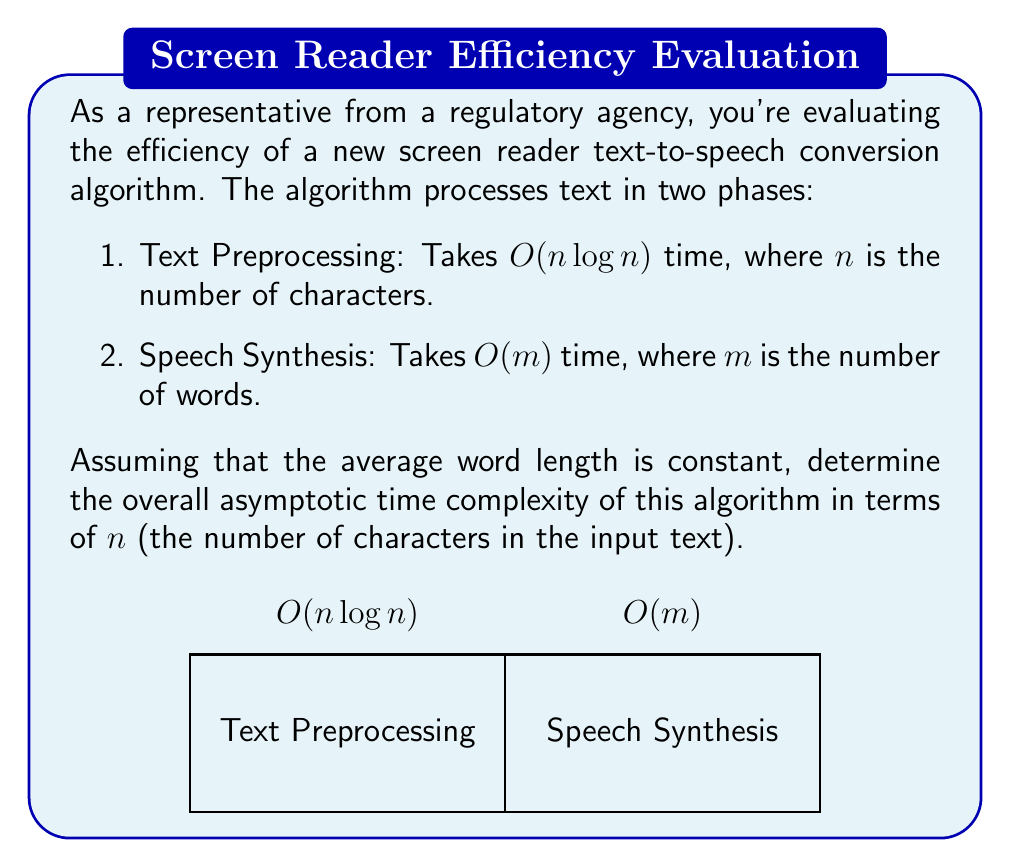Can you solve this math problem? To determine the overall asymptotic time complexity, we need to analyze both phases of the algorithm:

1. Text Preprocessing: $O(n \log n)$, where $n$ is the number of characters.

2. Speech Synthesis: $O(m)$, where $m$ is the number of words.

Given that the average word length is constant, we can establish a relationship between $n$ and $m$:

$m = \frac{n}{c}$, where $c$ is the average word length (a constant).

Therefore, we can express the Speech Synthesis complexity in terms of $n$:

$O(m) = O(\frac{n}{c}) = O(n)$

Now, we have two complexity terms:
1. $O(n \log n)$ for Text Preprocessing
2. $O(n)$ for Speech Synthesis

To find the overall complexity, we take the maximum of these two terms:

$O(\max(n \log n, n))$

Since $n \log n$ grows faster than $n$ for large values of $n$, the overall asymptotic time complexity is dominated by the Text Preprocessing phase:

$O(n \log n)$

This complexity ensures that our analysis accounts for the worst-case scenario, which is crucial for regulatory compliance and ensuring consistent performance across various text inputs.
Answer: $O(n \log n)$ 